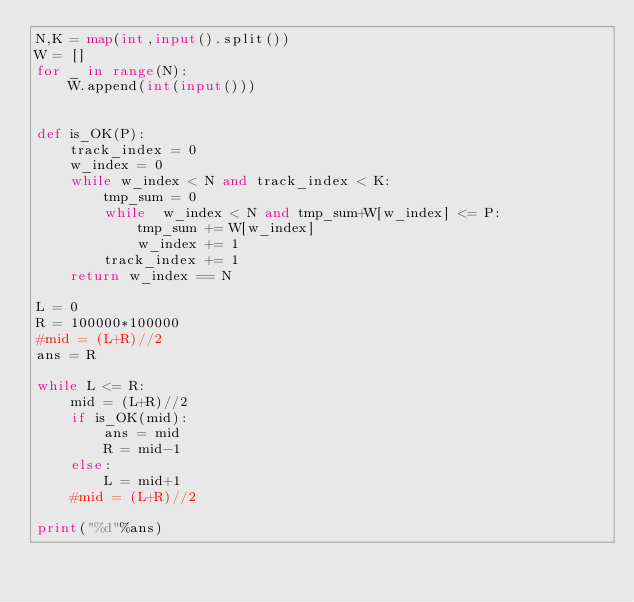<code> <loc_0><loc_0><loc_500><loc_500><_Python_>N,K = map(int,input().split())
W = []
for _ in range(N):
    W.append(int(input()))


def is_OK(P):
    track_index = 0
    w_index = 0
    while w_index < N and track_index < K:
        tmp_sum = 0
        while  w_index < N and tmp_sum+W[w_index] <= P:
            tmp_sum += W[w_index]
            w_index += 1
        track_index += 1
    return w_index == N

L = 0
R = 100000*100000
#mid = (L+R)//2
ans = R

while L <= R:
    mid = (L+R)//2
    if is_OK(mid):
        ans = mid
        R = mid-1
    else:
        L = mid+1
    #mid = (L+R)//2

print("%d"%ans)

</code> 